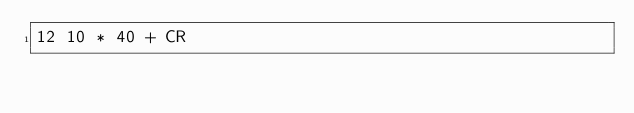<code> <loc_0><loc_0><loc_500><loc_500><_Forth_>12 10 * 40 + CR
</code> 